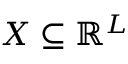Convert formula to latex. <formula><loc_0><loc_0><loc_500><loc_500>X \subseteq \mathbb { R } ^ { L }</formula> 